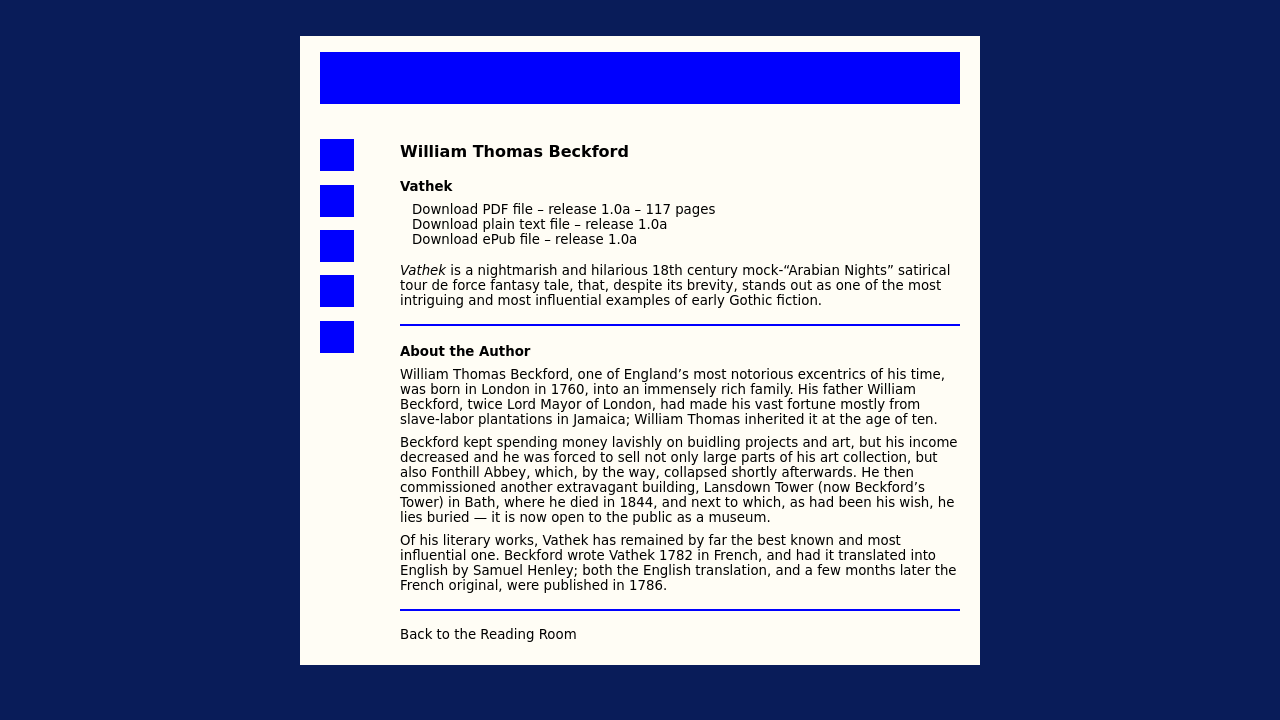Can you explain more about William Beckford's influences in writing Vathek? Certainly! Beckford was heavily influenced by the exotic and imaginative elements of the East and the popular 'Orientalism' trend in Europe during his time. His travels and vast scholarly interests helped him to create 'Vathek,' which combines the supernatural with a poignant critique of decadence and corruption in society. 